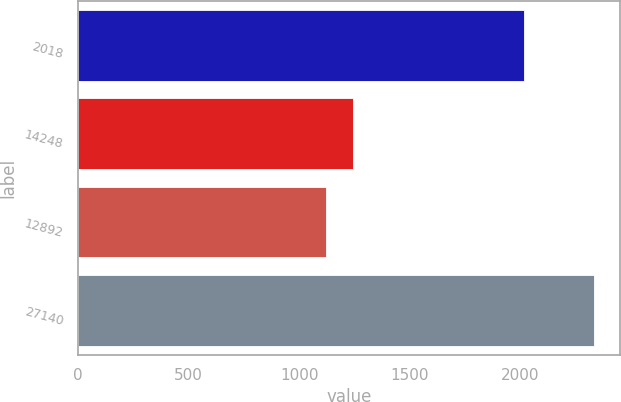Convert chart to OTSL. <chart><loc_0><loc_0><loc_500><loc_500><bar_chart><fcel>2018<fcel>14248<fcel>12892<fcel>27140<nl><fcel>2016<fcel>1244.48<fcel>1123.4<fcel>2334.2<nl></chart> 